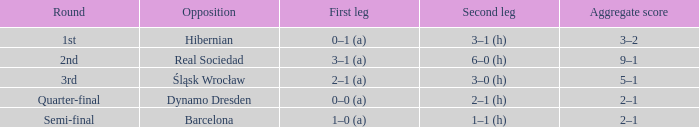What was the initial stage of the semi-final? 1–0 (a). 